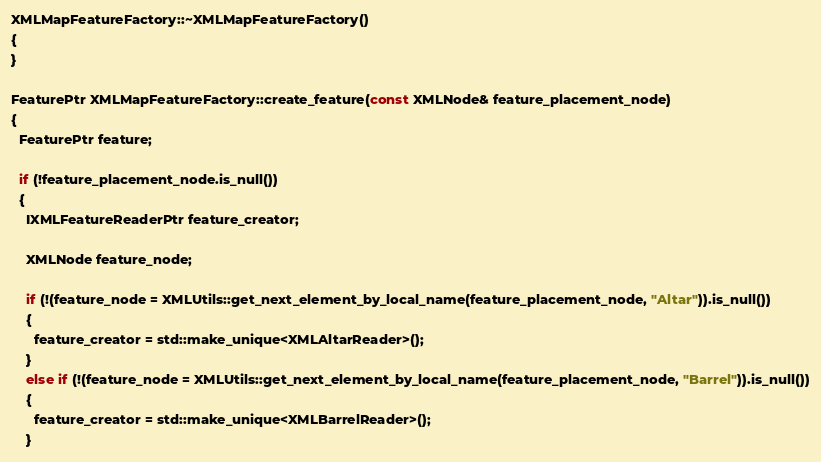Convert code to text. <code><loc_0><loc_0><loc_500><loc_500><_C++_>XMLMapFeatureFactory::~XMLMapFeatureFactory()
{
}

FeaturePtr XMLMapFeatureFactory::create_feature(const XMLNode& feature_placement_node)
{
  FeaturePtr feature;

  if (!feature_placement_node.is_null())
  {
    IXMLFeatureReaderPtr feature_creator;

    XMLNode feature_node;

    if (!(feature_node = XMLUtils::get_next_element_by_local_name(feature_placement_node, "Altar")).is_null())
    {
      feature_creator = std::make_unique<XMLAltarReader>();
    }
    else if (!(feature_node = XMLUtils::get_next_element_by_local_name(feature_placement_node, "Barrel")).is_null())
    {
      feature_creator = std::make_unique<XMLBarrelReader>();
    }</code> 